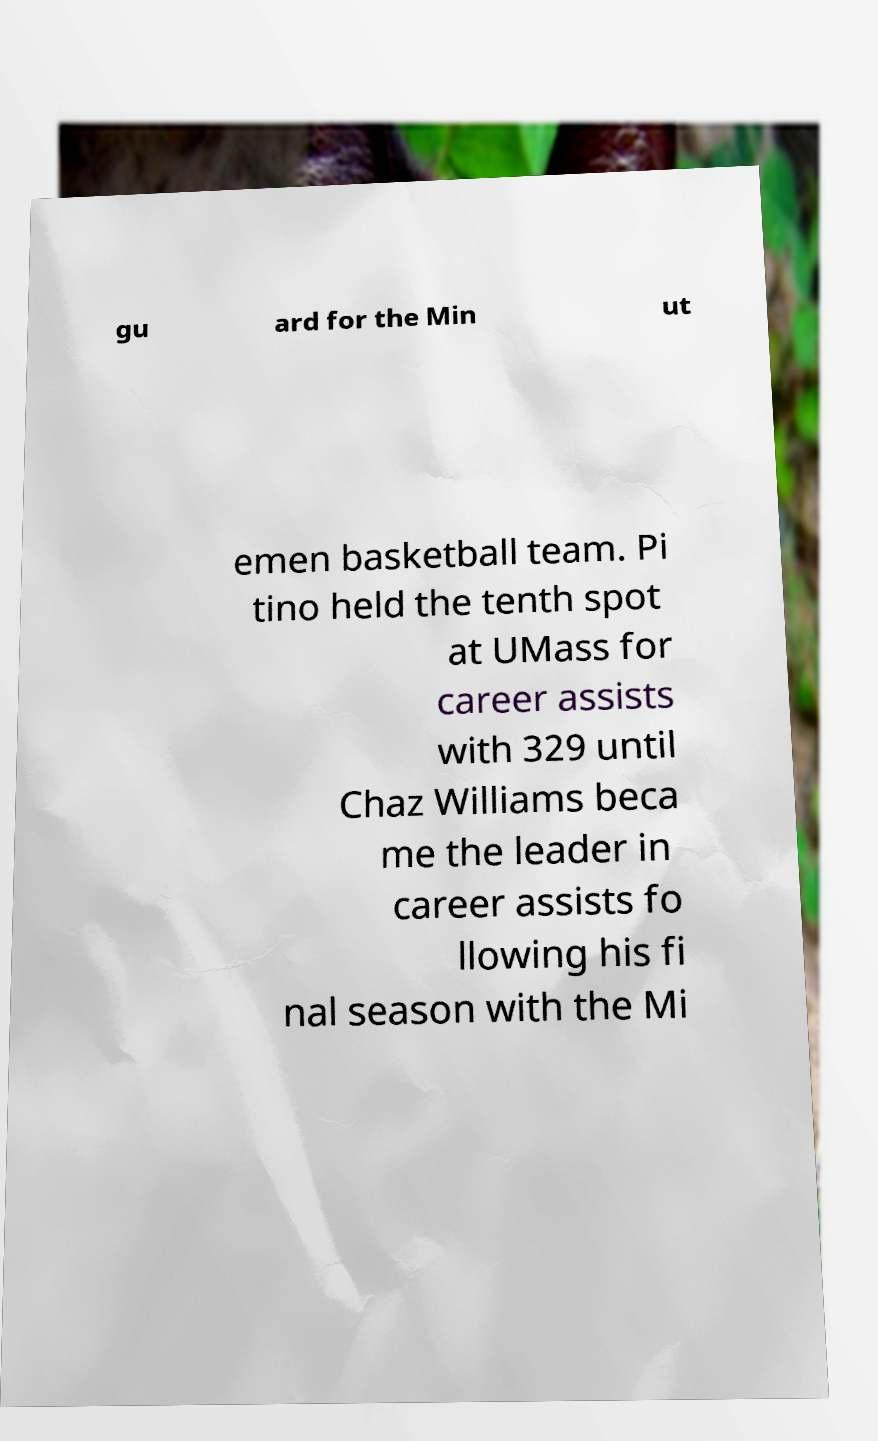Could you assist in decoding the text presented in this image and type it out clearly? gu ard for the Min ut emen basketball team. Pi tino held the tenth spot at UMass for career assists with 329 until Chaz Williams beca me the leader in career assists fo llowing his fi nal season with the Mi 